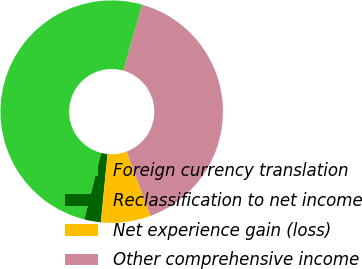Convert chart to OTSL. <chart><loc_0><loc_0><loc_500><loc_500><pie_chart><fcel>Foreign currency translation<fcel>Reclassification to net income<fcel>Net experience gain (loss)<fcel>Other comprehensive income<nl><fcel>50.45%<fcel>2.41%<fcel>7.22%<fcel>39.92%<nl></chart> 